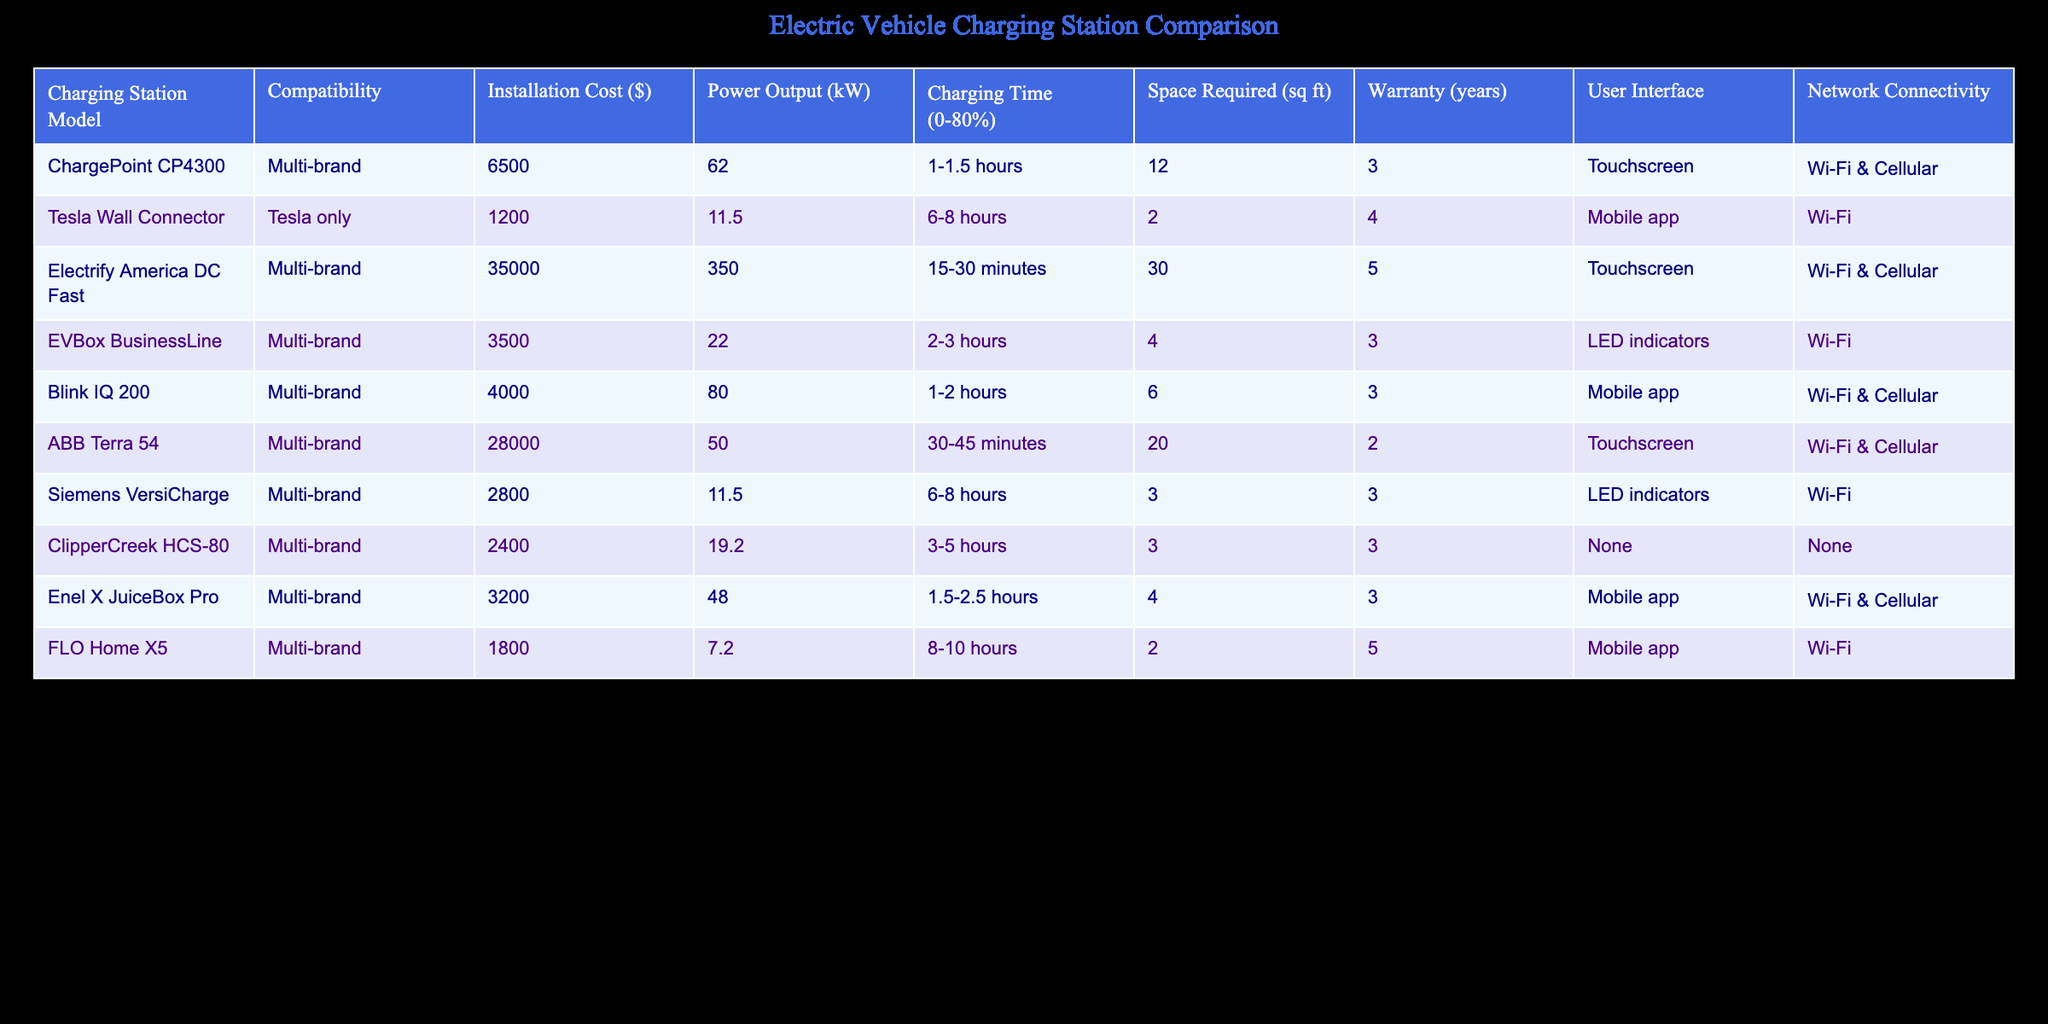What is the installation cost of the ChargePoint CP4300 charging station? The installation cost is listed in the table under the column "Installation Cost ($)" for the ChargePoint CP4300 model. The value is 6500.
Answer: 6500 Which charging station has the highest power output? The power output is provided in the "Power Output (kW)" column. The Blink IQ 200 has the highest value at 80 kW.
Answer: 80 kW Is the Tesla Wall Connector compatible with multi-brand vehicles? The compatibility for the Tesla Wall Connector is listed as "Tesla only", which means it is not compatible with multi-brand vehicles.
Answer: No What is the average installation cost of all the charging stations? To find the average installation cost, we sum all the installation costs from the table: 6500 + 1200 + 35000 + 3500 + 4000 + 28000 + 2800 + 2400 + 3200 + 1800 = 47500. There are 10 charging stations, so the average is 47500 / 10 = 4750.
Answer: 4750 Which charging station has the longest charging time to reach 80%? The charging time to reach 80% is provided in the "Charging Time (0-80%)" column. The Tesla Wall Connector has the longest time listed at 6-8 hours.
Answer: 6-8 hours Are all charging stations equipped with a touchscreen user interface? The "User Interface" column shows that not all stations have a touchscreen; for example, the ClipperCreek HCS-80 has no user interface.
Answer: No What is the total space required by the Electrify America DC Fast charging station and the ABB Terra 54 charging station combined? The space required for both stations is listed in the "Space Required (sq ft)" column. The Electrify America DC Fast requires 30 sq ft, and the ABB Terra 54 requires 20 sq ft. Adding these gives 30 + 20 = 50 sq ft.
Answer: 50 sq ft How many charging stations have a warranty of at least 4 years? By examining the "Warranty (years)" column, only the Tesla Wall Connector (4 years) and the FLO Home X5 (5 years) meet this criterion. Therefore, there are 2 stations.
Answer: 2 Does the Enel X JuiceBox Pro charging station have network connectivity? The "Network Connectivity" column indicates that the Enel X JuiceBox Pro has Wi-Fi & Cellular connectivity.
Answer: Yes 